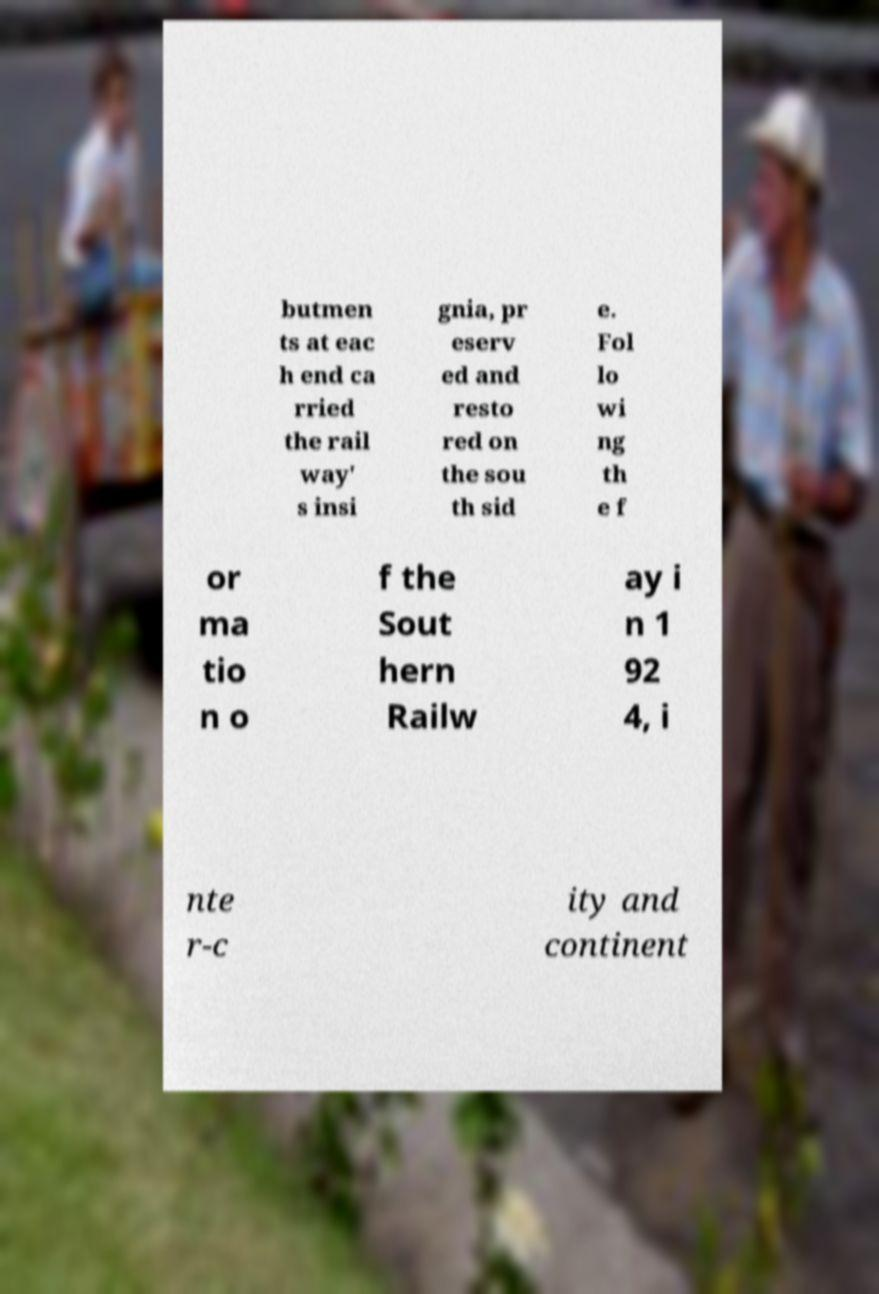There's text embedded in this image that I need extracted. Can you transcribe it verbatim? butmen ts at eac h end ca rried the rail way' s insi gnia, pr eserv ed and resto red on the sou th sid e. Fol lo wi ng th e f or ma tio n o f the Sout hern Railw ay i n 1 92 4, i nte r-c ity and continent 